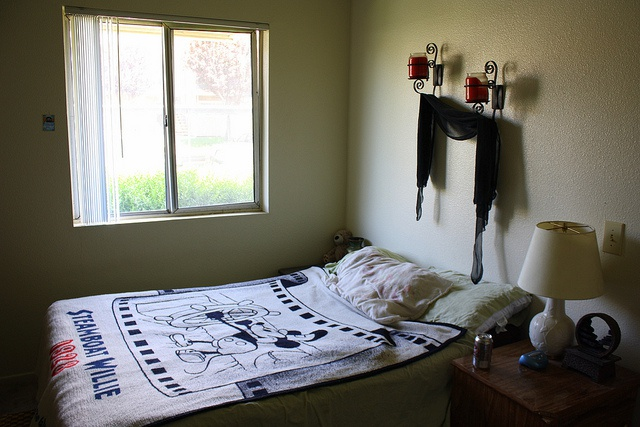Describe the objects in this image and their specific colors. I can see a bed in black, lavender, and darkgray tones in this image. 